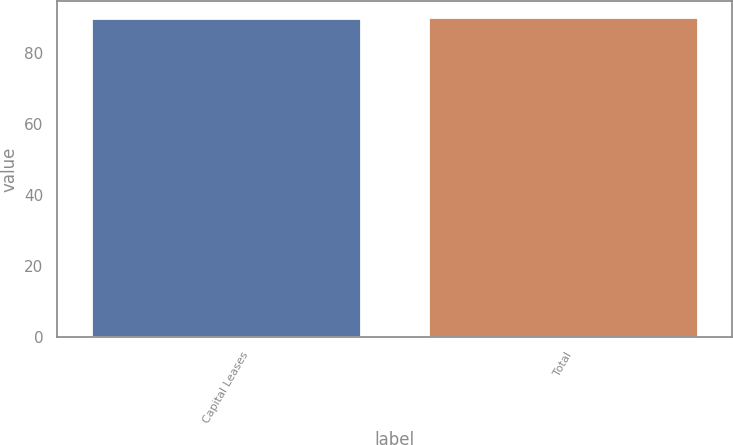<chart> <loc_0><loc_0><loc_500><loc_500><bar_chart><fcel>Capital Leases<fcel>Total<nl><fcel>90<fcel>90.1<nl></chart> 